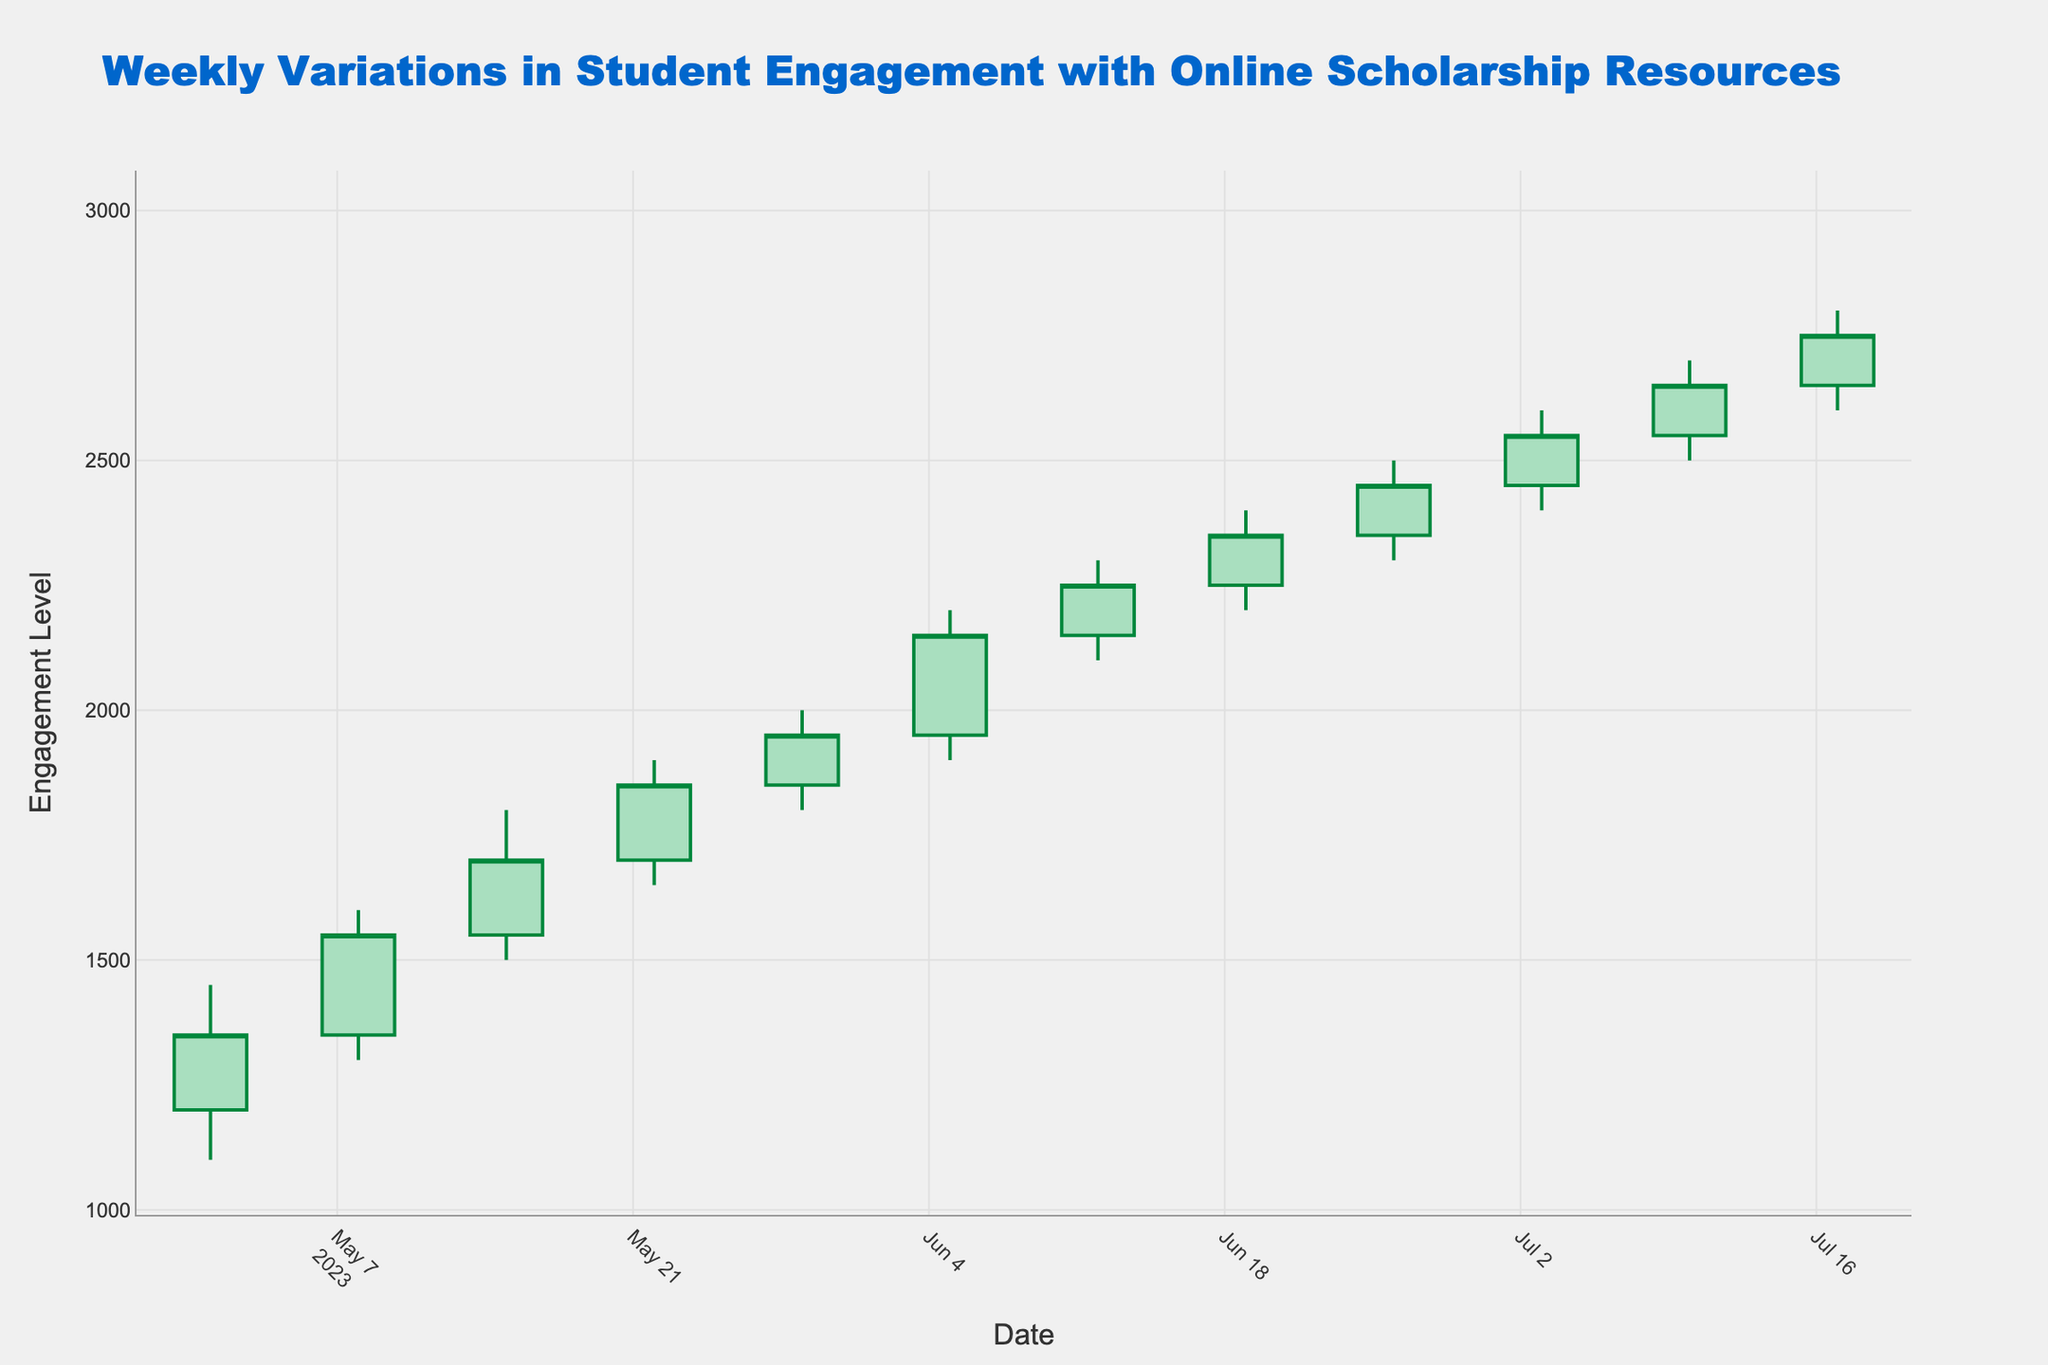What's the highest engagement level recorded in the given period? Look at the highest value of the High column in the chart, which is 2800 on 2023-07-17.
Answer: 2800 Which week shows the largest difference between the opening and closing engagement levels? Calculate the difference between Open and Close for each week and compare them. The week of 2023-05-08 has the largest difference (1550 - 1350 = 200).
Answer: 2023-05-08 Describe the overall trend in student engagement with online scholarship resources over the given period. Observe that the Close values consistently increase every week, indicating a rising trend in student engagement over the given period.
Answer: Increasing trend How does the closing engagement level on 2023-06-05 compare to the closing engagement level on 2023-07-10? Compare the Close values for 2023-06-05 (2150) and 2023-07-10 (2650). The engagement is higher on 2023-07-10.
Answer: Higher on 2023-07-10 What is the average of the closing engagement levels for June 2023? Sum the Close values for 2023-06-05, 2023-06-12, 2023-06-19, and 2023-06-26, then divide by 4. (2150 + 2250 + 2350 + 2450) / 4 = 2300.
Answer: 2300 Which week has the smallest range of engagement levels? Find the difference between High and Low for each week, the smallest range is found for 2023-05-01 (1450 - 1100 = 350).
Answer: 2023-05-01 Between which two consecutive weeks did the closing engagement level increase the most? Compare changes in Close values between consecutive weeks. The largest increase is from 2023-06-26 to 2023-07-03 (2550 - 2450 = 100).
Answer: 2023-06-26 to 2023-07-03 What is the total increase in closing engagement level from 2023-05-01 to 2023-07-17? Subtract the Close value on 2023-05-01 from the Close value on 2023-07-17. (2750 - 1350 = 1400).
Answer: 1400 What can be inferred from the color of the candlesticks about the weekly changes in student engagement? In this chart, green candlesticks represent an increase in engagement (Close > Open), and red candlesticks represent a decrease (Close < Open). All candlesticks are green, indicating increases every week.
Answer: Consistent increase 